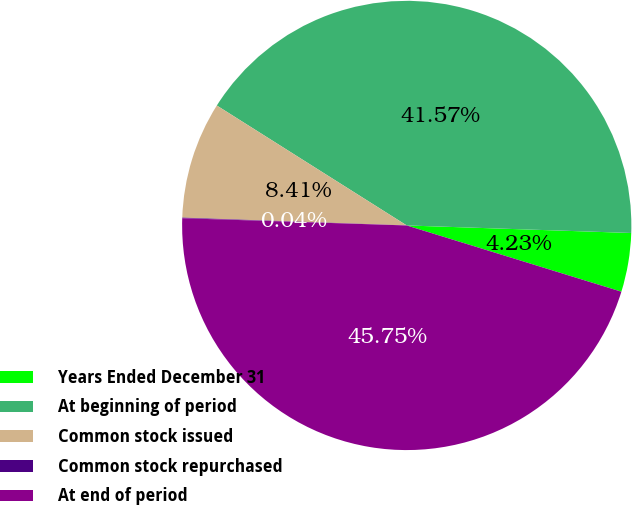Convert chart. <chart><loc_0><loc_0><loc_500><loc_500><pie_chart><fcel>Years Ended December 31<fcel>At beginning of period<fcel>Common stock issued<fcel>Common stock repurchased<fcel>At end of period<nl><fcel>4.23%<fcel>41.57%<fcel>8.41%<fcel>0.04%<fcel>45.75%<nl></chart> 